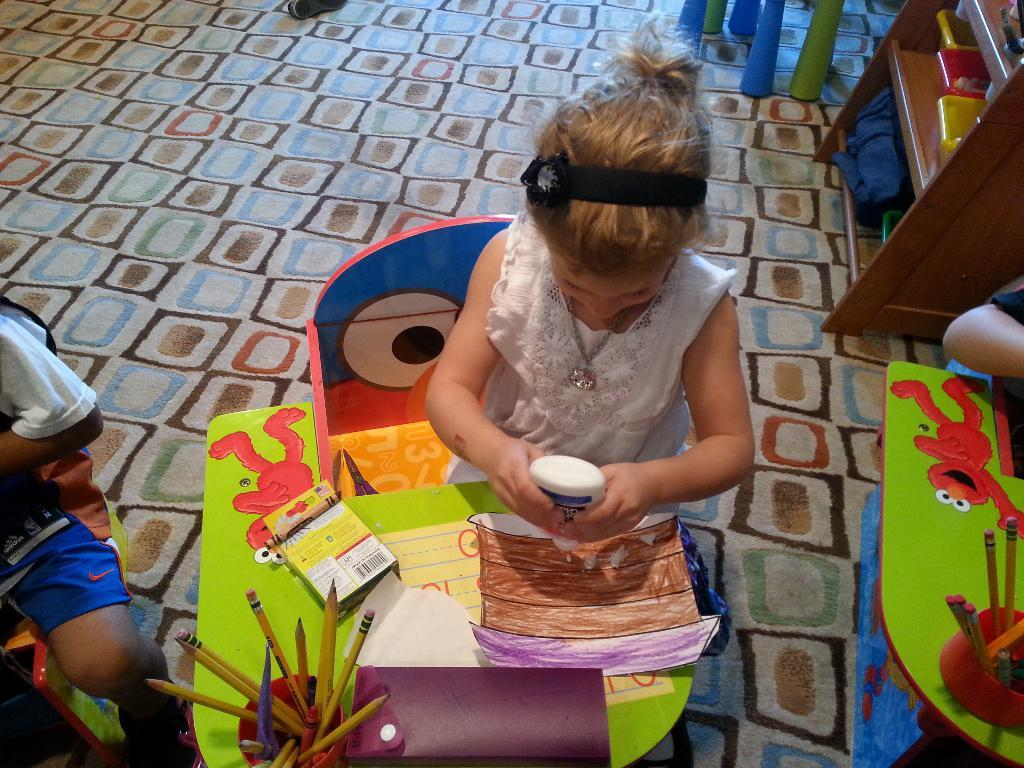Who is the main subject in the image? There is a little girl in the image. What is the girl doing in the image? The girl is sitting on a chair and doing a drawing. What is the girl wearing in the image? The girl is wearing a white dress. What can be seen near the girl in the image? There is a cup with pencils in the image. What type of sponge can be seen being used in the drawing process in the image? There is no sponge visible in the image, and the drawing process is not shown in detail. 